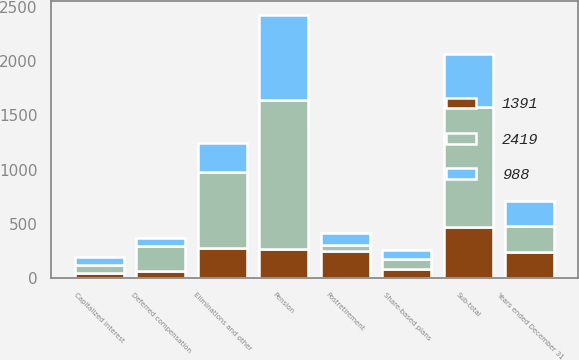Convert chart to OTSL. <chart><loc_0><loc_0><loc_500><loc_500><stacked_bar_chart><ecel><fcel>Years ended December 31<fcel>Share-based plans<fcel>Deferred compensation<fcel>Capitalized interest<fcel>Eliminations and other<fcel>Sub-total<fcel>Pension<fcel>Postretirement<nl><fcel>2419<fcel>238<fcel>95<fcel>238<fcel>69<fcel>703<fcel>1105<fcel>1374<fcel>60<nl><fcel>988<fcel>238<fcel>81<fcel>75<fcel>70<fcel>266<fcel>492<fcel>787<fcel>112<nl><fcel>1391<fcel>238<fcel>83<fcel>61<fcel>51<fcel>276<fcel>471<fcel>269<fcel>248<nl></chart> 